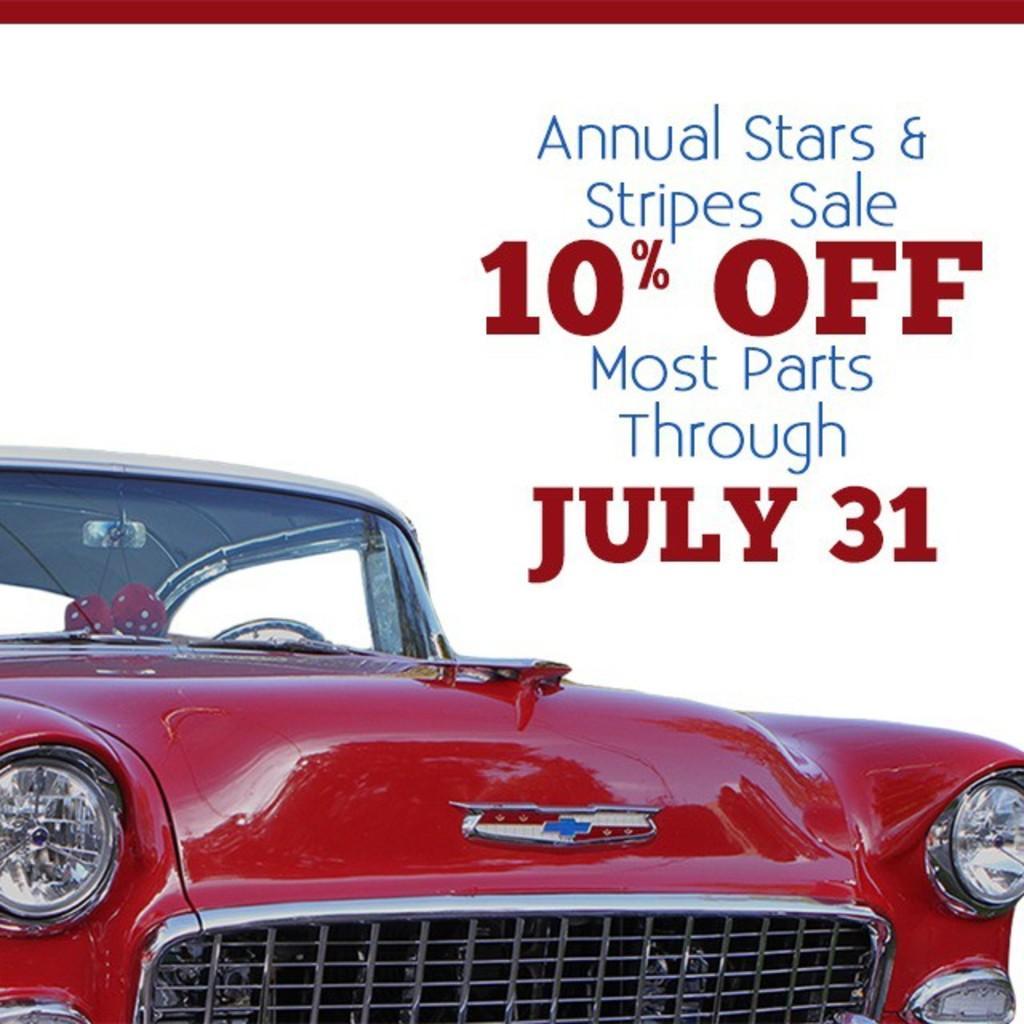Can you describe this image briefly? In this image there is a poster on which text is written, there is a red color car truncated, the background of the image is white. 